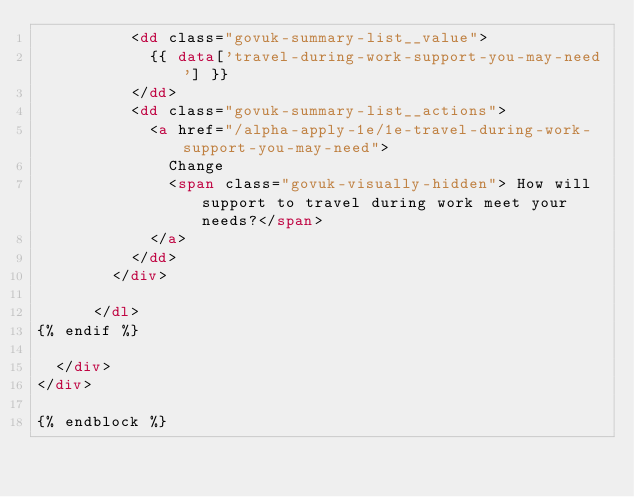Convert code to text. <code><loc_0><loc_0><loc_500><loc_500><_HTML_>          <dd class="govuk-summary-list__value">
            {{ data['travel-during-work-support-you-may-need'] }}
          </dd>
          <dd class="govuk-summary-list__actions">
            <a href="/alpha-apply-1e/1e-travel-during-work-support-you-may-need">
              Change
              <span class="govuk-visually-hidden"> How will support to travel during work meet your needs?</span>
            </a>
          </dd>
        </div>

      </dl>
{% endif %}

  </div>
</div>

{% endblock %}
</code> 